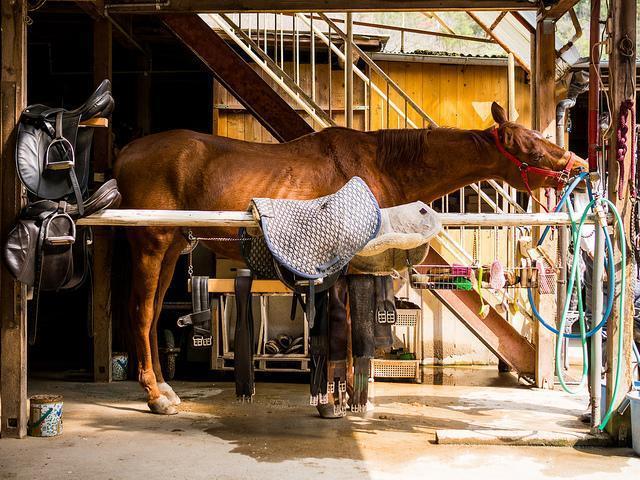How many saddles are there?
Give a very brief answer. 2. How many people are wearing white jerseys?
Give a very brief answer. 0. 